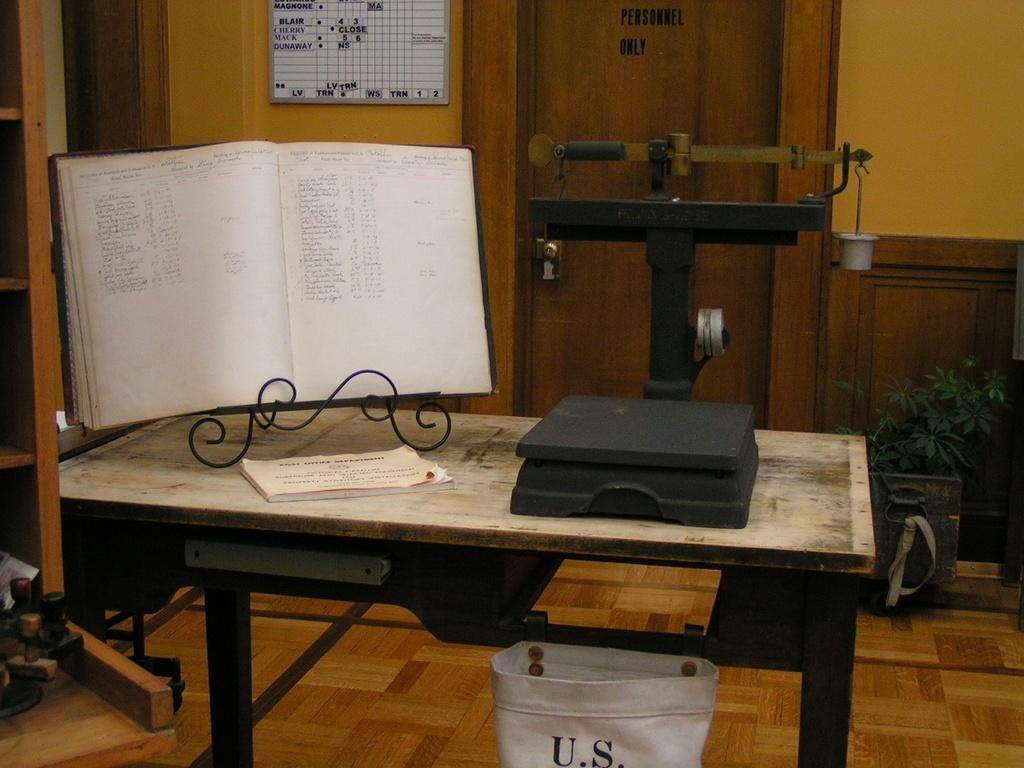How would you summarize this image in a sentence or two? In this image I can see table on the table , I can see a book ,stand,machine visible , under the table I can see white basket , on the right side I can see flower pot , plant , , in the middle there is a door, wall , on the wall I can see notice paper, on the left side I can see rack. 